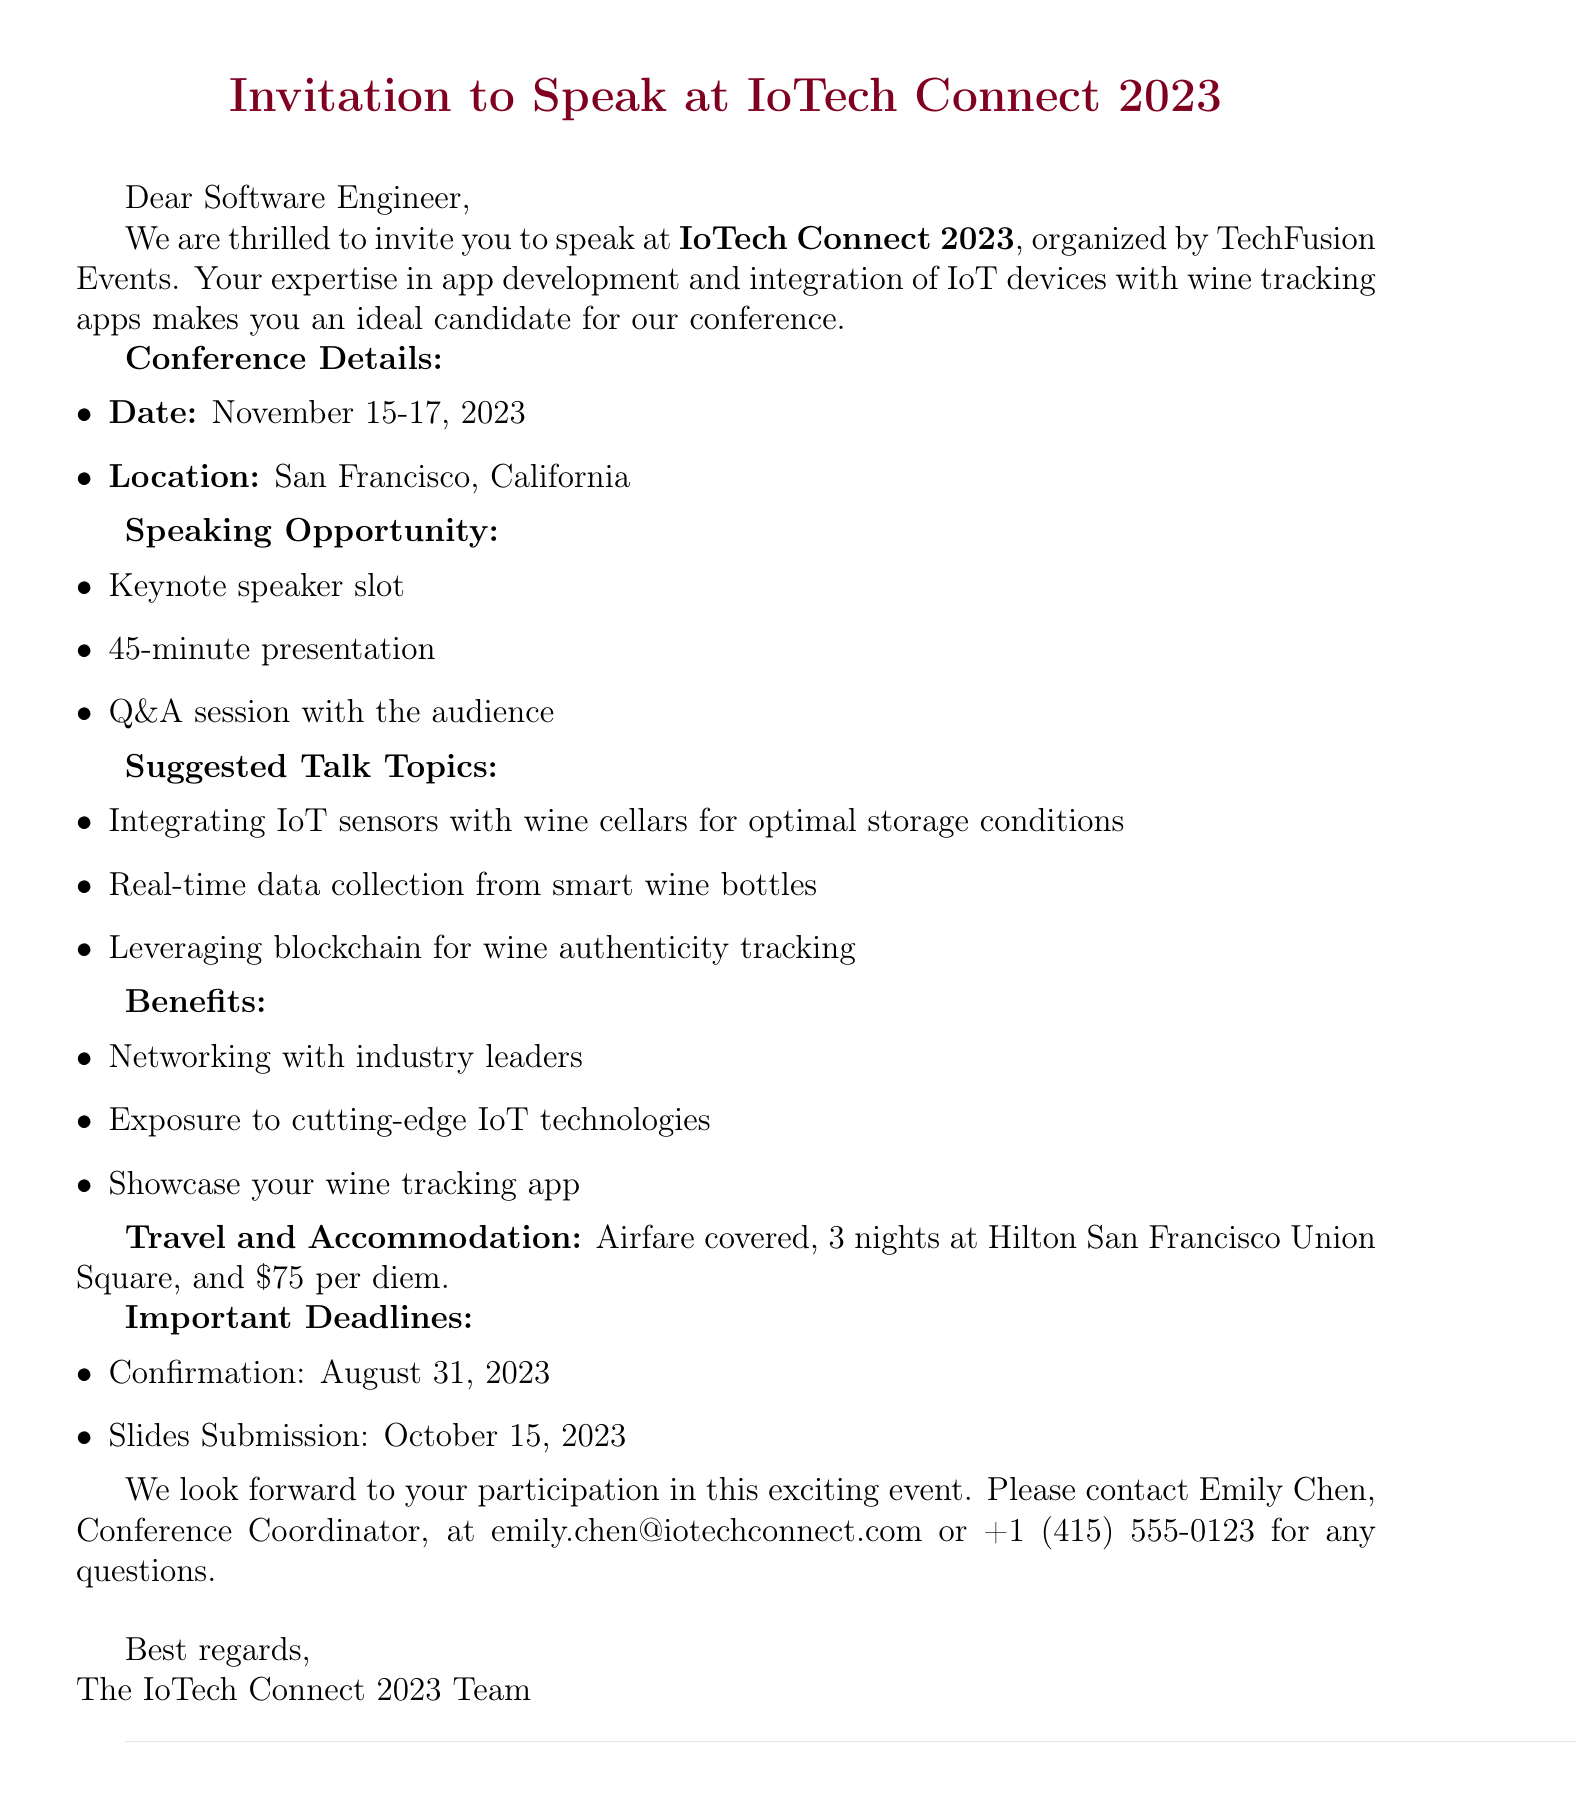What are the dates of the conference? The document specifies the conference dates as November 15-17, 2023.
Answer: November 15-17, 2023 Who is the organizer of the event? The invitation states that the conference is organized by TechFusion Events.
Answer: TechFusion Events How long is the presentation slot? The document mentions that each presentation slot is 45 minutes long.
Answer: 45 minutes What is covered for travel? The travel section indicates that airfare is covered by the conference.
Answer: Airfare What is the contact person's email? The invitation provides Emily Chen's email as the contact for further inquiries.
Answer: emily.chen@iotechconnect.com What are two suggested talk topics? The document lists several topics, but two examples are provided: integrating IoT sensors with wine cellars and real-time data collection from smart wine bottles.
Answer: Integrating IoT sensors with wine cellars, real-time data collection from smart wine bottles What benefits are mentioned for speaking at the conference? The invitation outlines several benefits including networking opportunities and exposure to cutting-edge IoT technologies.
Answer: Networking with industry leaders, exposure to cutting-edge IoT technologies What is the per diem amount for meals? According to the travel and accommodation section, the per diem for meals and incidentals is specified.
Answer: $75 per day 